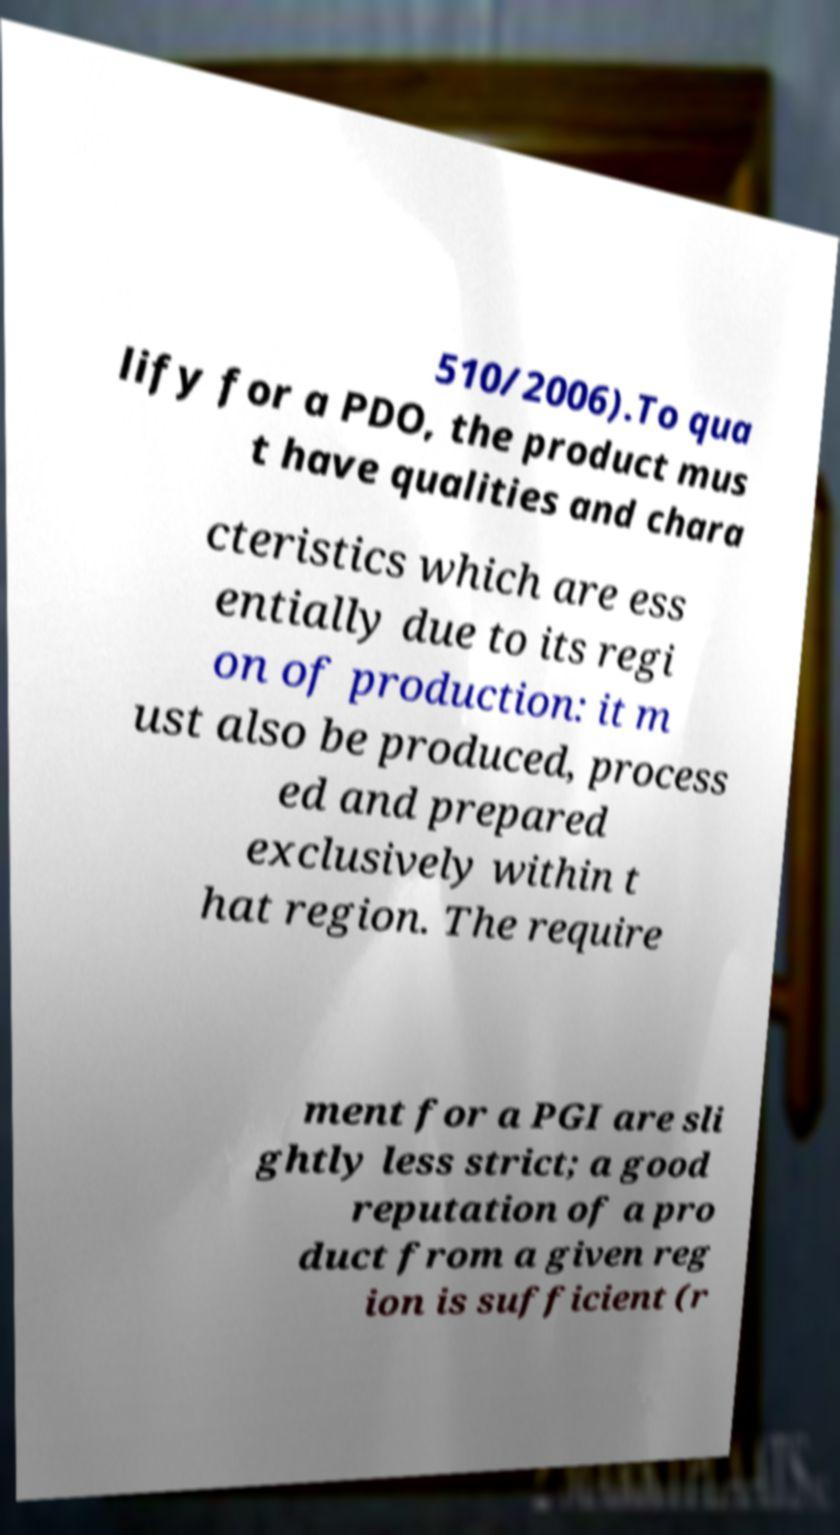There's text embedded in this image that I need extracted. Can you transcribe it verbatim? 510/2006).To qua lify for a PDO, the product mus t have qualities and chara cteristics which are ess entially due to its regi on of production: it m ust also be produced, process ed and prepared exclusively within t hat region. The require ment for a PGI are sli ghtly less strict; a good reputation of a pro duct from a given reg ion is sufficient (r 